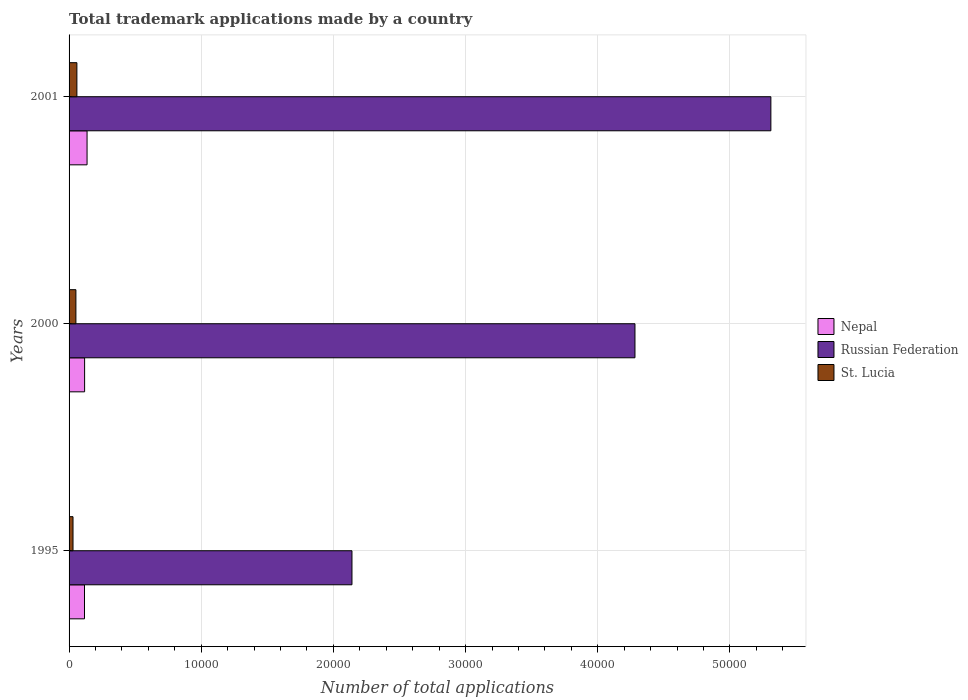How many groups of bars are there?
Offer a terse response. 3. Are the number of bars per tick equal to the number of legend labels?
Make the answer very short. Yes. How many bars are there on the 1st tick from the top?
Your answer should be very brief. 3. How many bars are there on the 2nd tick from the bottom?
Your answer should be compact. 3. What is the number of applications made by in Nepal in 2000?
Your response must be concise. 1175. Across all years, what is the maximum number of applications made by in Russian Federation?
Ensure brevity in your answer.  5.31e+04. Across all years, what is the minimum number of applications made by in Nepal?
Keep it short and to the point. 1167. In which year was the number of applications made by in Nepal maximum?
Ensure brevity in your answer.  2001. In which year was the number of applications made by in Nepal minimum?
Your answer should be compact. 1995. What is the total number of applications made by in Nepal in the graph?
Your answer should be compact. 3703. What is the difference between the number of applications made by in Russian Federation in 1995 and that in 2000?
Your answer should be compact. -2.14e+04. What is the difference between the number of applications made by in Nepal in 2000 and the number of applications made by in Russian Federation in 2001?
Make the answer very short. -5.19e+04. What is the average number of applications made by in Nepal per year?
Your answer should be very brief. 1234.33. In the year 2001, what is the difference between the number of applications made by in Russian Federation and number of applications made by in St. Lucia?
Keep it short and to the point. 5.25e+04. What is the ratio of the number of applications made by in Russian Federation in 2000 to that in 2001?
Your answer should be compact. 0.81. Is the number of applications made by in St. Lucia in 1995 less than that in 2001?
Provide a short and direct response. Yes. What is the difference between the highest and the second highest number of applications made by in Nepal?
Provide a succinct answer. 186. What is the difference between the highest and the lowest number of applications made by in St. Lucia?
Make the answer very short. 294. In how many years, is the number of applications made by in St. Lucia greater than the average number of applications made by in St. Lucia taken over all years?
Give a very brief answer. 2. What does the 3rd bar from the top in 1995 represents?
Ensure brevity in your answer.  Nepal. What does the 2nd bar from the bottom in 2001 represents?
Provide a succinct answer. Russian Federation. Is it the case that in every year, the sum of the number of applications made by in Russian Federation and number of applications made by in Nepal is greater than the number of applications made by in St. Lucia?
Give a very brief answer. Yes. How many bars are there?
Ensure brevity in your answer.  9. Are all the bars in the graph horizontal?
Give a very brief answer. Yes. How many years are there in the graph?
Your answer should be compact. 3. What is the difference between two consecutive major ticks on the X-axis?
Your response must be concise. 10000. Does the graph contain any zero values?
Keep it short and to the point. No. How are the legend labels stacked?
Offer a terse response. Vertical. What is the title of the graph?
Keep it short and to the point. Total trademark applications made by a country. Does "Poland" appear as one of the legend labels in the graph?
Make the answer very short. No. What is the label or title of the X-axis?
Your answer should be compact. Number of total applications. What is the label or title of the Y-axis?
Your response must be concise. Years. What is the Number of total applications of Nepal in 1995?
Make the answer very short. 1167. What is the Number of total applications in Russian Federation in 1995?
Your answer should be very brief. 2.14e+04. What is the Number of total applications of St. Lucia in 1995?
Make the answer very short. 298. What is the Number of total applications of Nepal in 2000?
Give a very brief answer. 1175. What is the Number of total applications of Russian Federation in 2000?
Your response must be concise. 4.28e+04. What is the Number of total applications in St. Lucia in 2000?
Ensure brevity in your answer.  517. What is the Number of total applications in Nepal in 2001?
Provide a short and direct response. 1361. What is the Number of total applications of Russian Federation in 2001?
Provide a succinct answer. 5.31e+04. What is the Number of total applications in St. Lucia in 2001?
Offer a very short reply. 592. Across all years, what is the maximum Number of total applications of Nepal?
Provide a succinct answer. 1361. Across all years, what is the maximum Number of total applications of Russian Federation?
Offer a very short reply. 5.31e+04. Across all years, what is the maximum Number of total applications in St. Lucia?
Your answer should be very brief. 592. Across all years, what is the minimum Number of total applications in Nepal?
Ensure brevity in your answer.  1167. Across all years, what is the minimum Number of total applications in Russian Federation?
Offer a very short reply. 2.14e+04. Across all years, what is the minimum Number of total applications in St. Lucia?
Your response must be concise. 298. What is the total Number of total applications of Nepal in the graph?
Your answer should be very brief. 3703. What is the total Number of total applications of Russian Federation in the graph?
Offer a very short reply. 1.17e+05. What is the total Number of total applications of St. Lucia in the graph?
Your answer should be very brief. 1407. What is the difference between the Number of total applications in Nepal in 1995 and that in 2000?
Make the answer very short. -8. What is the difference between the Number of total applications of Russian Federation in 1995 and that in 2000?
Make the answer very short. -2.14e+04. What is the difference between the Number of total applications in St. Lucia in 1995 and that in 2000?
Give a very brief answer. -219. What is the difference between the Number of total applications in Nepal in 1995 and that in 2001?
Offer a very short reply. -194. What is the difference between the Number of total applications in Russian Federation in 1995 and that in 2001?
Offer a very short reply. -3.17e+04. What is the difference between the Number of total applications of St. Lucia in 1995 and that in 2001?
Your answer should be very brief. -294. What is the difference between the Number of total applications in Nepal in 2000 and that in 2001?
Keep it short and to the point. -186. What is the difference between the Number of total applications in Russian Federation in 2000 and that in 2001?
Make the answer very short. -1.03e+04. What is the difference between the Number of total applications in St. Lucia in 2000 and that in 2001?
Offer a very short reply. -75. What is the difference between the Number of total applications of Nepal in 1995 and the Number of total applications of Russian Federation in 2000?
Give a very brief answer. -4.16e+04. What is the difference between the Number of total applications of Nepal in 1995 and the Number of total applications of St. Lucia in 2000?
Give a very brief answer. 650. What is the difference between the Number of total applications in Russian Federation in 1995 and the Number of total applications in St. Lucia in 2000?
Keep it short and to the point. 2.09e+04. What is the difference between the Number of total applications of Nepal in 1995 and the Number of total applications of Russian Federation in 2001?
Offer a very short reply. -5.19e+04. What is the difference between the Number of total applications of Nepal in 1995 and the Number of total applications of St. Lucia in 2001?
Your response must be concise. 575. What is the difference between the Number of total applications of Russian Federation in 1995 and the Number of total applications of St. Lucia in 2001?
Your answer should be very brief. 2.08e+04. What is the difference between the Number of total applications in Nepal in 2000 and the Number of total applications in Russian Federation in 2001?
Provide a short and direct response. -5.19e+04. What is the difference between the Number of total applications of Nepal in 2000 and the Number of total applications of St. Lucia in 2001?
Provide a succinct answer. 583. What is the difference between the Number of total applications of Russian Federation in 2000 and the Number of total applications of St. Lucia in 2001?
Offer a terse response. 4.22e+04. What is the average Number of total applications in Nepal per year?
Make the answer very short. 1234.33. What is the average Number of total applications in Russian Federation per year?
Offer a terse response. 3.91e+04. What is the average Number of total applications of St. Lucia per year?
Your answer should be compact. 469. In the year 1995, what is the difference between the Number of total applications in Nepal and Number of total applications in Russian Federation?
Your response must be concise. -2.02e+04. In the year 1995, what is the difference between the Number of total applications in Nepal and Number of total applications in St. Lucia?
Offer a very short reply. 869. In the year 1995, what is the difference between the Number of total applications in Russian Federation and Number of total applications in St. Lucia?
Offer a very short reply. 2.11e+04. In the year 2000, what is the difference between the Number of total applications of Nepal and Number of total applications of Russian Federation?
Provide a succinct answer. -4.16e+04. In the year 2000, what is the difference between the Number of total applications in Nepal and Number of total applications in St. Lucia?
Ensure brevity in your answer.  658. In the year 2000, what is the difference between the Number of total applications of Russian Federation and Number of total applications of St. Lucia?
Ensure brevity in your answer.  4.23e+04. In the year 2001, what is the difference between the Number of total applications in Nepal and Number of total applications in Russian Federation?
Make the answer very short. -5.17e+04. In the year 2001, what is the difference between the Number of total applications of Nepal and Number of total applications of St. Lucia?
Keep it short and to the point. 769. In the year 2001, what is the difference between the Number of total applications in Russian Federation and Number of total applications in St. Lucia?
Your response must be concise. 5.25e+04. What is the ratio of the Number of total applications of Nepal in 1995 to that in 2000?
Give a very brief answer. 0.99. What is the ratio of the Number of total applications in Russian Federation in 1995 to that in 2000?
Provide a succinct answer. 0.5. What is the ratio of the Number of total applications of St. Lucia in 1995 to that in 2000?
Your response must be concise. 0.58. What is the ratio of the Number of total applications of Nepal in 1995 to that in 2001?
Provide a succinct answer. 0.86. What is the ratio of the Number of total applications in Russian Federation in 1995 to that in 2001?
Ensure brevity in your answer.  0.4. What is the ratio of the Number of total applications in St. Lucia in 1995 to that in 2001?
Make the answer very short. 0.5. What is the ratio of the Number of total applications in Nepal in 2000 to that in 2001?
Give a very brief answer. 0.86. What is the ratio of the Number of total applications of Russian Federation in 2000 to that in 2001?
Make the answer very short. 0.81. What is the ratio of the Number of total applications of St. Lucia in 2000 to that in 2001?
Make the answer very short. 0.87. What is the difference between the highest and the second highest Number of total applications of Nepal?
Offer a very short reply. 186. What is the difference between the highest and the second highest Number of total applications of Russian Federation?
Give a very brief answer. 1.03e+04. What is the difference between the highest and the lowest Number of total applications in Nepal?
Offer a very short reply. 194. What is the difference between the highest and the lowest Number of total applications of Russian Federation?
Offer a very short reply. 3.17e+04. What is the difference between the highest and the lowest Number of total applications in St. Lucia?
Make the answer very short. 294. 